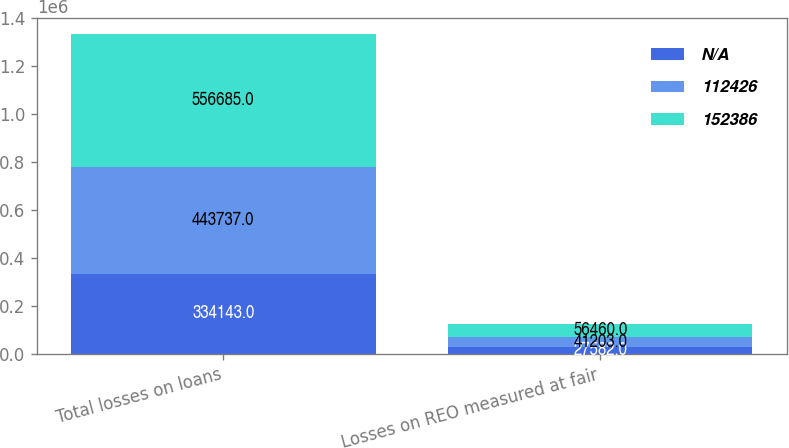<chart> <loc_0><loc_0><loc_500><loc_500><stacked_bar_chart><ecel><fcel>Total losses on loans<fcel>Losses on REO measured at fair<nl><fcel>nan<fcel>334143<fcel>27582<nl><fcel>112426<fcel>443737<fcel>41203<nl><fcel>152386<fcel>556685<fcel>56460<nl></chart> 